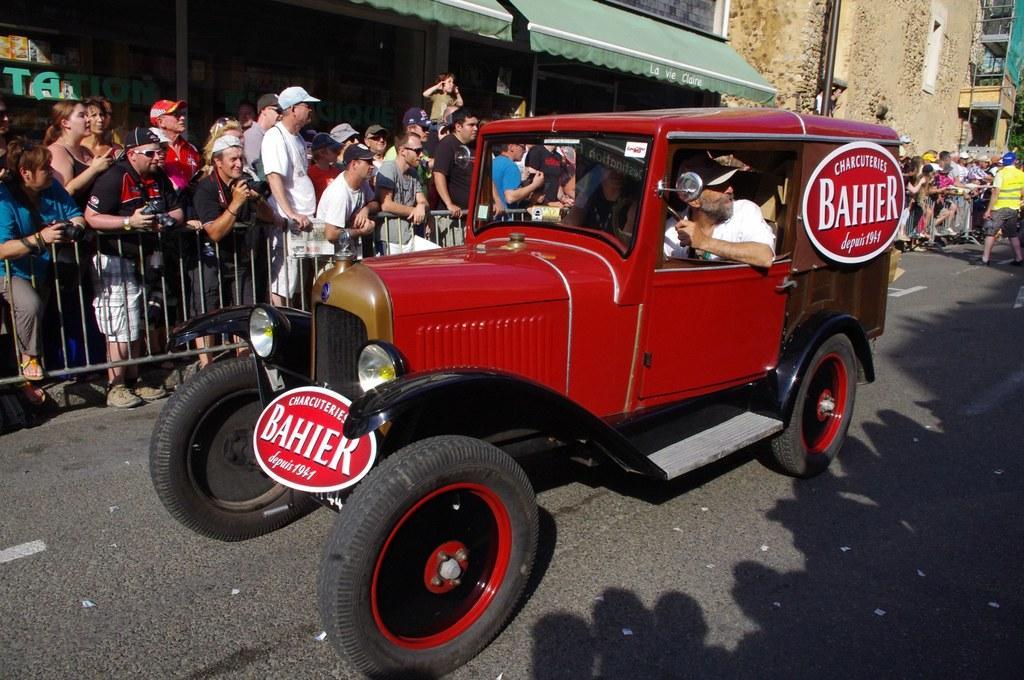How would you summarize this image in a sentence or two? In a picture a person is driving a car on the road there are many people watching them there are some buildings near to the road there are some poles near to the road on the car there are board on the there is some text. 